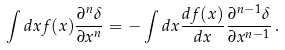Convert formula to latex. <formula><loc_0><loc_0><loc_500><loc_500>\int d x f ( x ) \frac { \partial ^ { n } \delta } { \partial x ^ { n } } = - \int d x \frac { d f ( x ) } { d x } \frac { \partial ^ { n - 1 } \delta } { \partial x ^ { n - 1 } } \, .</formula> 